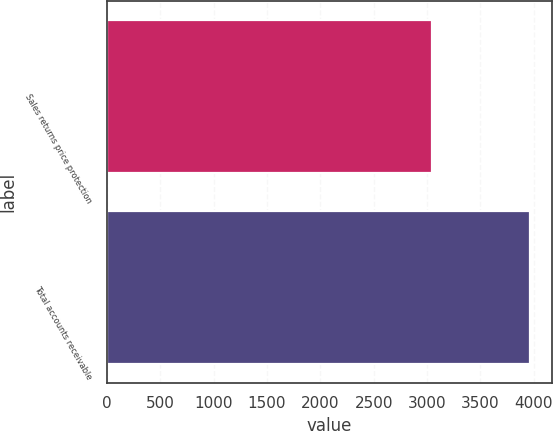<chart> <loc_0><loc_0><loc_500><loc_500><bar_chart><fcel>Sales returns price protection<fcel>Total accounts receivable<nl><fcel>3042<fcel>3968<nl></chart> 